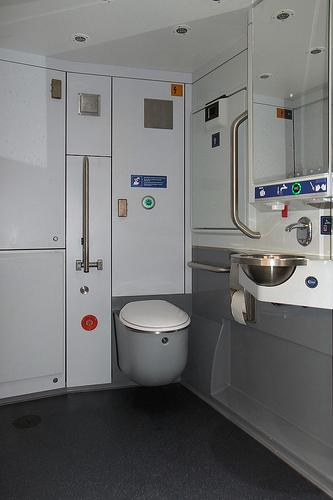Question: when will these bathroom pics stop?
Choices:
A. The last one.
B. When the camera runs out of film.
C. When the photographer decides.
D. Soon I hope.
Answer with the letter. Answer: D Question: what are those bars for?
Choices:
A. A mirror.
B. Toothbrushes.
C. To keep people from falling.
D. Soap.
Answer with the letter. Answer: C Question: what is above the sink?
Choices:
A. A faucet.
B. Soap.
C. A mirror.
D. Toothbrushes.
Answer with the letter. Answer: A 